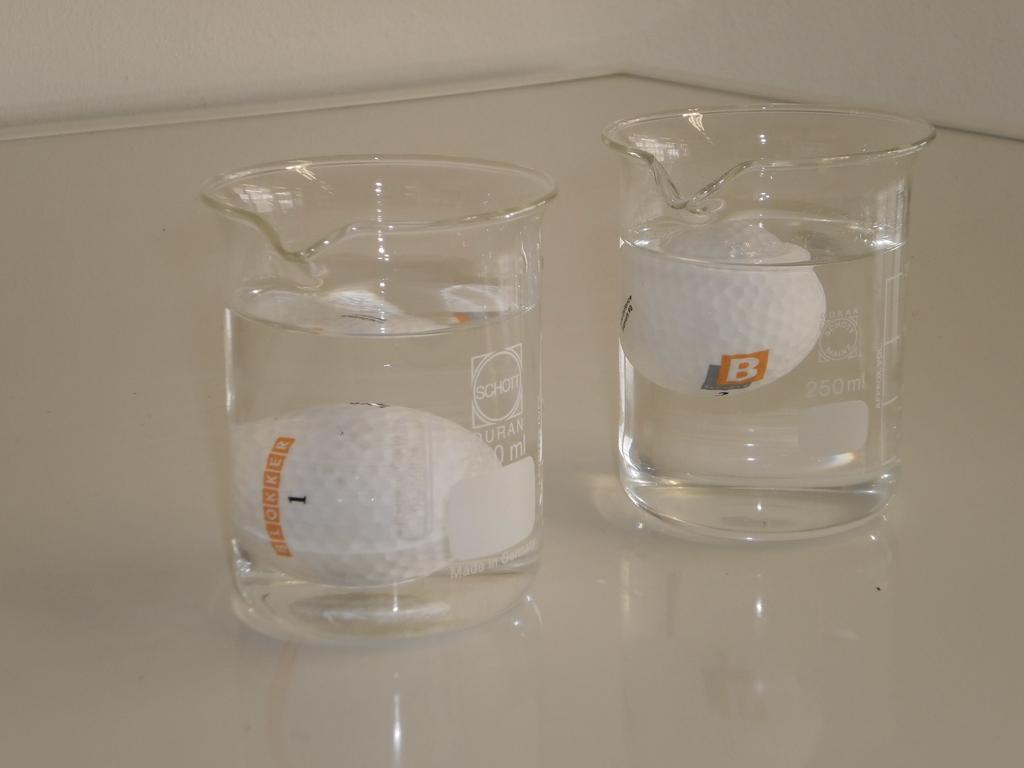<image>
Share a concise interpretation of the image provided. Glass beaker by Schott with golf ball inside. 